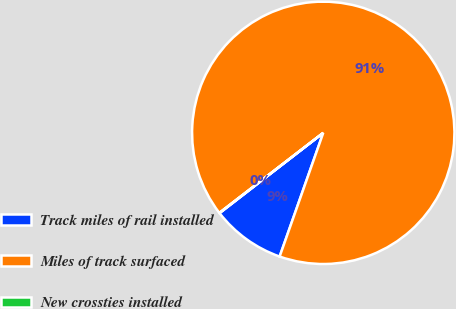Convert chart. <chart><loc_0><loc_0><loc_500><loc_500><pie_chart><fcel>Track miles of rail installed<fcel>Miles of track surfaced<fcel>New crossties installed<nl><fcel>9.12%<fcel>90.83%<fcel>0.04%<nl></chart> 